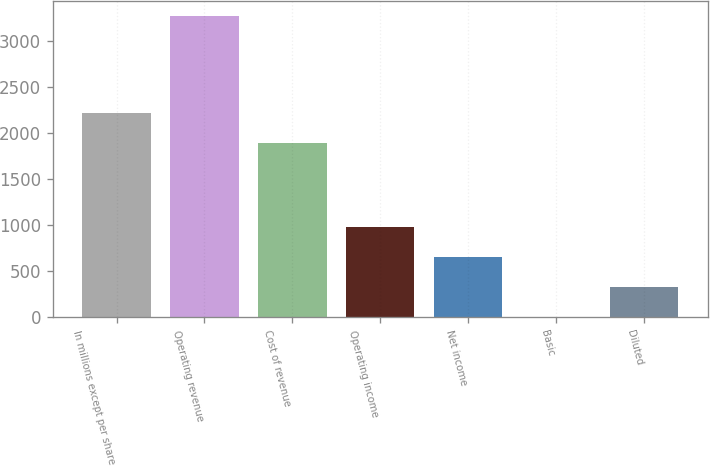Convert chart. <chart><loc_0><loc_0><loc_500><loc_500><bar_chart><fcel>In millions except per share<fcel>Operating revenue<fcel>Cost of revenue<fcel>Operating income<fcel>Net income<fcel>Basic<fcel>Diluted<nl><fcel>2223.27<fcel>3274<fcel>1896<fcel>983.1<fcel>655.83<fcel>1.29<fcel>328.56<nl></chart> 